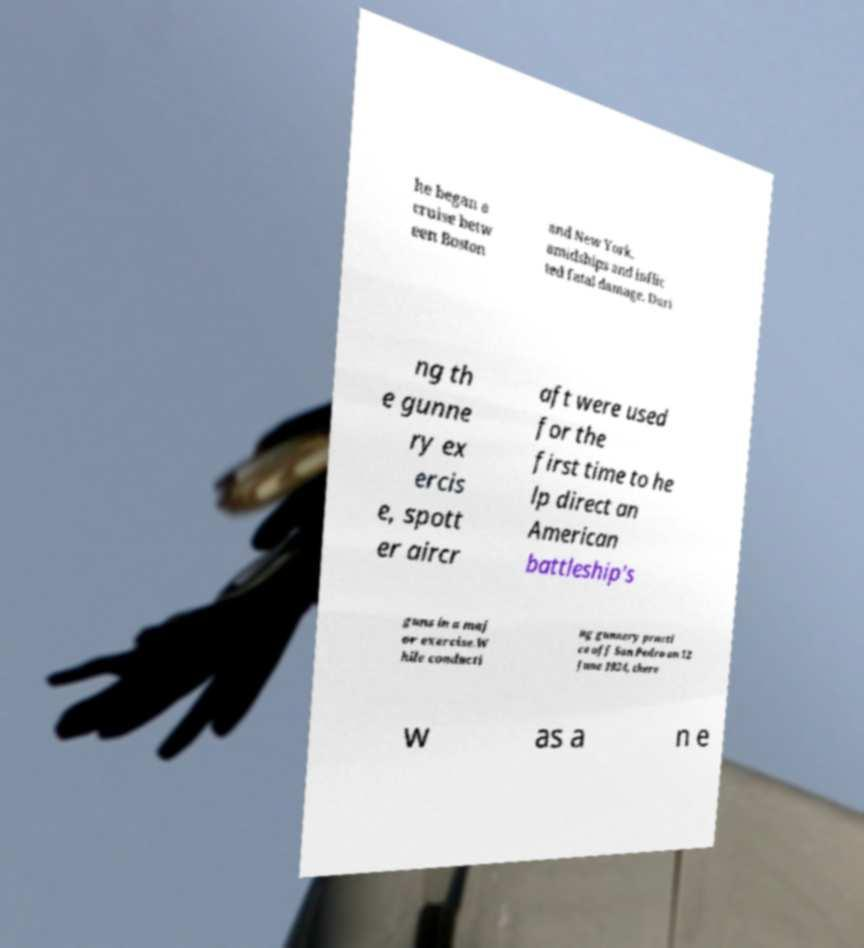Can you read and provide the text displayed in the image?This photo seems to have some interesting text. Can you extract and type it out for me? he began a cruise betw een Boston and New York. amidships and inflic ted fatal damage. Duri ng th e gunne ry ex ercis e, spott er aircr aft were used for the first time to he lp direct an American battleship's guns in a maj or exercise.W hile conducti ng gunnery practi ce off San Pedro on 12 June 1924, there w as a n e 